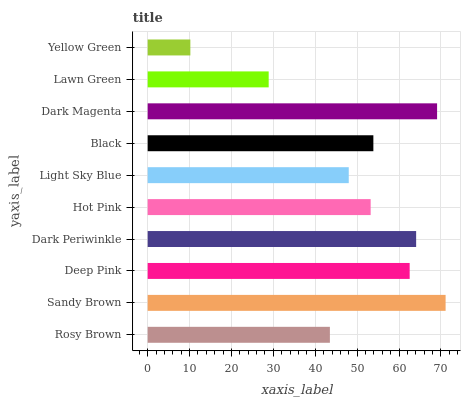Is Yellow Green the minimum?
Answer yes or no. Yes. Is Sandy Brown the maximum?
Answer yes or no. Yes. Is Deep Pink the minimum?
Answer yes or no. No. Is Deep Pink the maximum?
Answer yes or no. No. Is Sandy Brown greater than Deep Pink?
Answer yes or no. Yes. Is Deep Pink less than Sandy Brown?
Answer yes or no. Yes. Is Deep Pink greater than Sandy Brown?
Answer yes or no. No. Is Sandy Brown less than Deep Pink?
Answer yes or no. No. Is Black the high median?
Answer yes or no. Yes. Is Hot Pink the low median?
Answer yes or no. Yes. Is Hot Pink the high median?
Answer yes or no. No. Is Light Sky Blue the low median?
Answer yes or no. No. 